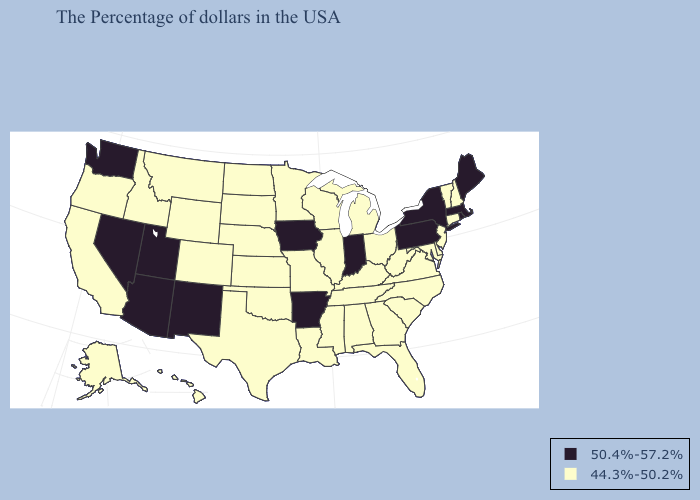Name the states that have a value in the range 50.4%-57.2%?
Quick response, please. Maine, Massachusetts, Rhode Island, New York, Pennsylvania, Indiana, Arkansas, Iowa, New Mexico, Utah, Arizona, Nevada, Washington. Does the map have missing data?
Write a very short answer. No. Name the states that have a value in the range 50.4%-57.2%?
Quick response, please. Maine, Massachusetts, Rhode Island, New York, Pennsylvania, Indiana, Arkansas, Iowa, New Mexico, Utah, Arizona, Nevada, Washington. What is the highest value in states that border Alabama?
Write a very short answer. 44.3%-50.2%. Does Nevada have the lowest value in the West?
Answer briefly. No. Does Maine have the lowest value in the USA?
Concise answer only. No. Name the states that have a value in the range 44.3%-50.2%?
Concise answer only. New Hampshire, Vermont, Connecticut, New Jersey, Delaware, Maryland, Virginia, North Carolina, South Carolina, West Virginia, Ohio, Florida, Georgia, Michigan, Kentucky, Alabama, Tennessee, Wisconsin, Illinois, Mississippi, Louisiana, Missouri, Minnesota, Kansas, Nebraska, Oklahoma, Texas, South Dakota, North Dakota, Wyoming, Colorado, Montana, Idaho, California, Oregon, Alaska, Hawaii. Does Colorado have the highest value in the USA?
Concise answer only. No. What is the highest value in the MidWest ?
Keep it brief. 50.4%-57.2%. How many symbols are there in the legend?
Short answer required. 2. Which states hav the highest value in the West?
Be succinct. New Mexico, Utah, Arizona, Nevada, Washington. What is the value of Idaho?
Keep it brief. 44.3%-50.2%. Name the states that have a value in the range 50.4%-57.2%?
Concise answer only. Maine, Massachusetts, Rhode Island, New York, Pennsylvania, Indiana, Arkansas, Iowa, New Mexico, Utah, Arizona, Nevada, Washington. Which states have the lowest value in the West?
Quick response, please. Wyoming, Colorado, Montana, Idaho, California, Oregon, Alaska, Hawaii. 